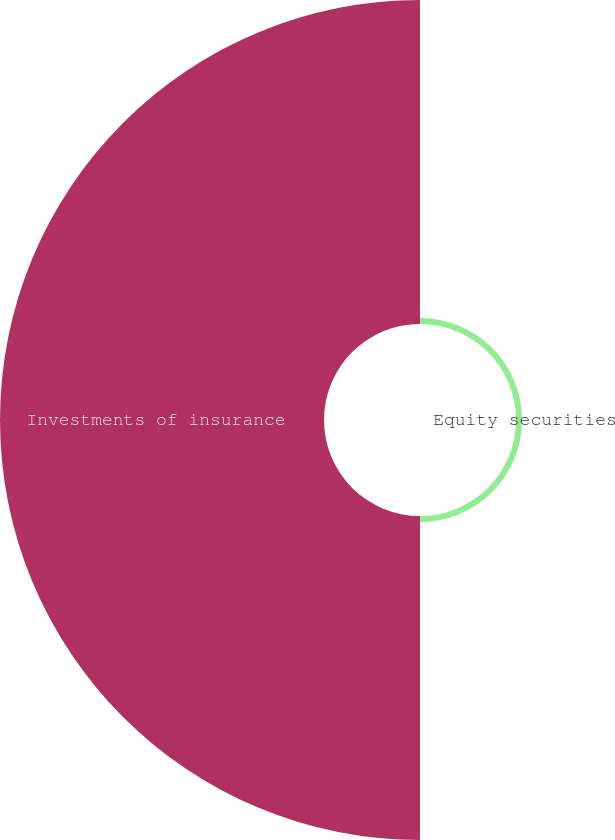Convert chart. <chart><loc_0><loc_0><loc_500><loc_500><pie_chart><fcel>Equity securities<fcel>Investments of insurance<nl><fcel>1.82%<fcel>98.18%<nl></chart> 